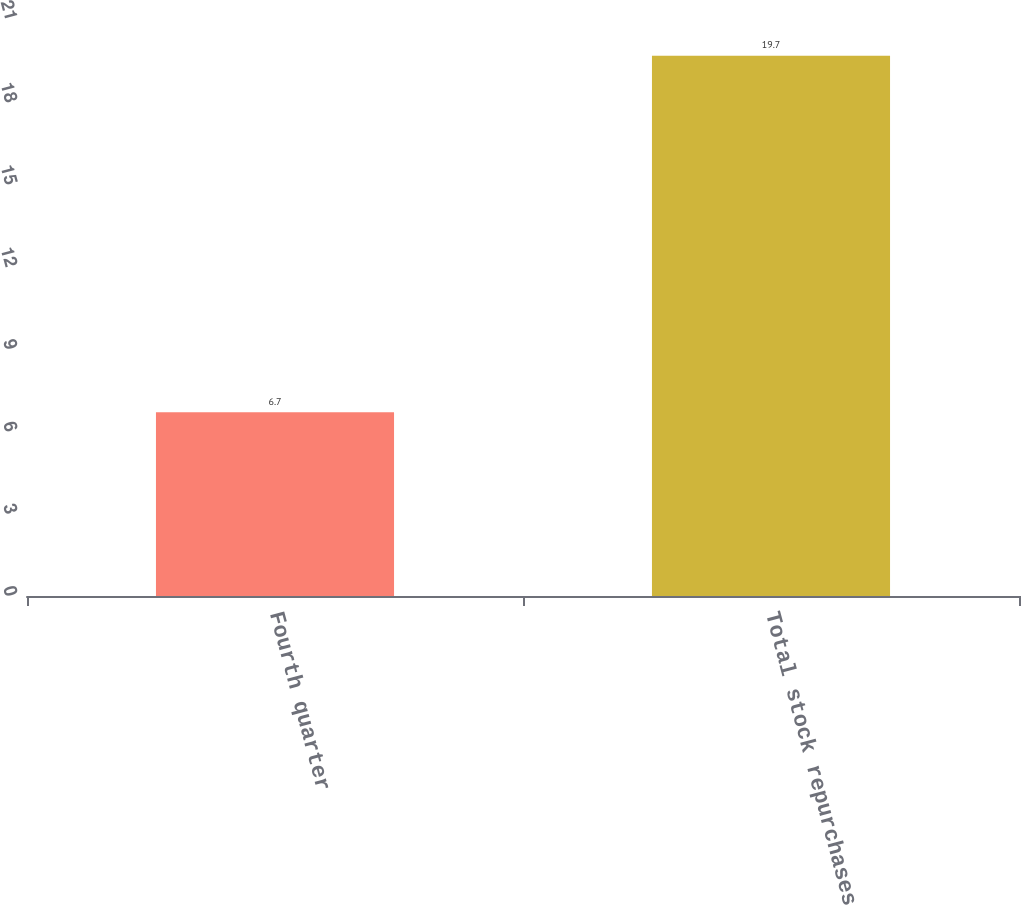Convert chart. <chart><loc_0><loc_0><loc_500><loc_500><bar_chart><fcel>Fourth quarter<fcel>Total stock repurchases<nl><fcel>6.7<fcel>19.7<nl></chart> 